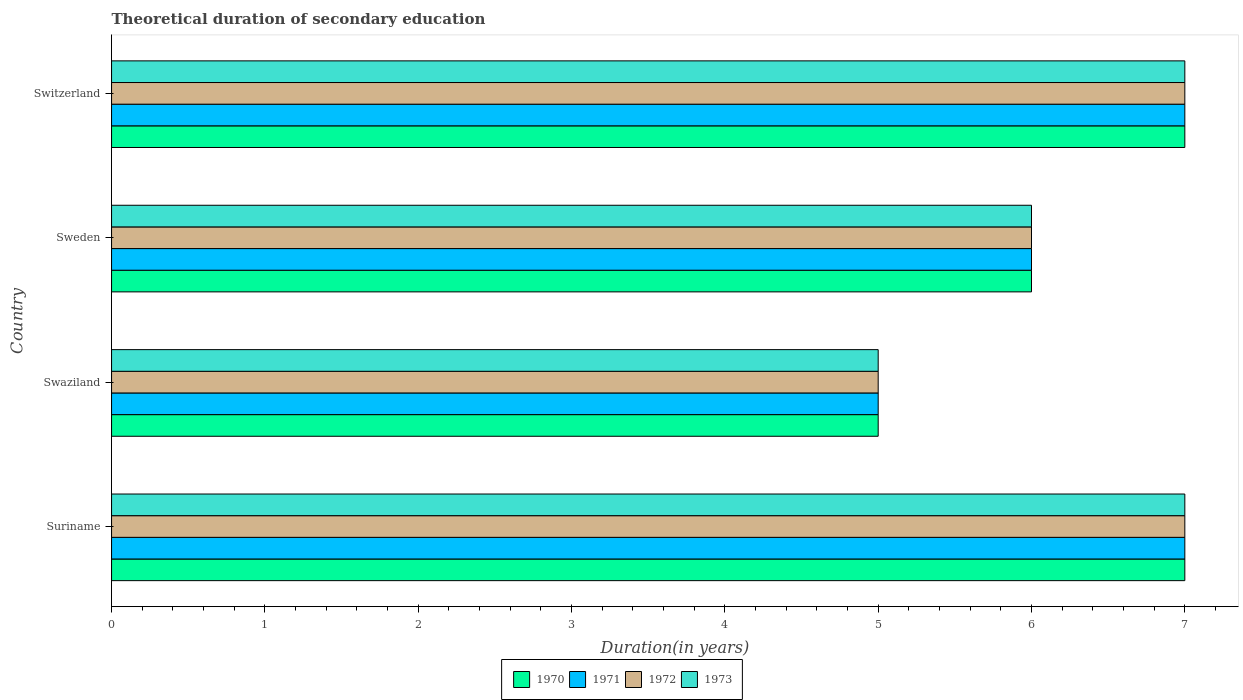Are the number of bars on each tick of the Y-axis equal?
Offer a terse response. Yes. How many bars are there on the 3rd tick from the top?
Offer a terse response. 4. How many bars are there on the 4th tick from the bottom?
Make the answer very short. 4. What is the label of the 1st group of bars from the top?
Provide a succinct answer. Switzerland. Across all countries, what is the minimum total theoretical duration of secondary education in 1971?
Your answer should be compact. 5. In which country was the total theoretical duration of secondary education in 1970 maximum?
Your response must be concise. Suriname. In which country was the total theoretical duration of secondary education in 1971 minimum?
Offer a terse response. Swaziland. What is the difference between the total theoretical duration of secondary education in 1973 in Switzerland and the total theoretical duration of secondary education in 1971 in Suriname?
Keep it short and to the point. 0. What is the average total theoretical duration of secondary education in 1972 per country?
Ensure brevity in your answer.  6.25. In how many countries, is the total theoretical duration of secondary education in 1970 greater than 3.8 years?
Give a very brief answer. 4. What is the ratio of the total theoretical duration of secondary education in 1973 in Suriname to that in Sweden?
Offer a terse response. 1.17. Is the total theoretical duration of secondary education in 1972 in Suriname less than that in Sweden?
Offer a very short reply. No. Is the difference between the total theoretical duration of secondary education in 1970 in Suriname and Swaziland greater than the difference between the total theoretical duration of secondary education in 1973 in Suriname and Swaziland?
Your response must be concise. No. What is the difference between the highest and the lowest total theoretical duration of secondary education in 1972?
Your answer should be compact. 2. Is the sum of the total theoretical duration of secondary education in 1972 in Swaziland and Sweden greater than the maximum total theoretical duration of secondary education in 1971 across all countries?
Provide a short and direct response. Yes. What does the 1st bar from the top in Sweden represents?
Keep it short and to the point. 1973. What does the 3rd bar from the bottom in Swaziland represents?
Provide a succinct answer. 1972. How many bars are there?
Your response must be concise. 16. What is the difference between two consecutive major ticks on the X-axis?
Keep it short and to the point. 1. Does the graph contain grids?
Ensure brevity in your answer.  No. How many legend labels are there?
Your answer should be compact. 4. What is the title of the graph?
Your answer should be compact. Theoretical duration of secondary education. What is the label or title of the X-axis?
Provide a short and direct response. Duration(in years). What is the label or title of the Y-axis?
Give a very brief answer. Country. What is the Duration(in years) of 1971 in Suriname?
Ensure brevity in your answer.  7. What is the Duration(in years) of 1972 in Suriname?
Your answer should be compact. 7. What is the Duration(in years) of 1971 in Swaziland?
Keep it short and to the point. 5. What is the Duration(in years) of 1973 in Swaziland?
Provide a short and direct response. 5. What is the Duration(in years) of 1970 in Sweden?
Make the answer very short. 6. What is the Duration(in years) in 1972 in Sweden?
Offer a terse response. 6. What is the Duration(in years) in 1970 in Switzerland?
Keep it short and to the point. 7. What is the Duration(in years) of 1971 in Switzerland?
Ensure brevity in your answer.  7. What is the Duration(in years) in 1972 in Switzerland?
Provide a succinct answer. 7. Across all countries, what is the maximum Duration(in years) in 1970?
Keep it short and to the point. 7. Across all countries, what is the maximum Duration(in years) of 1971?
Make the answer very short. 7. Across all countries, what is the maximum Duration(in years) of 1972?
Ensure brevity in your answer.  7. Across all countries, what is the minimum Duration(in years) of 1971?
Your answer should be compact. 5. Across all countries, what is the minimum Duration(in years) of 1972?
Offer a very short reply. 5. Across all countries, what is the minimum Duration(in years) in 1973?
Offer a terse response. 5. What is the total Duration(in years) of 1972 in the graph?
Offer a very short reply. 25. What is the total Duration(in years) of 1973 in the graph?
Offer a terse response. 25. What is the difference between the Duration(in years) in 1972 in Suriname and that in Swaziland?
Give a very brief answer. 2. What is the difference between the Duration(in years) of 1971 in Suriname and that in Sweden?
Offer a terse response. 1. What is the difference between the Duration(in years) in 1972 in Suriname and that in Sweden?
Your response must be concise. 1. What is the difference between the Duration(in years) in 1973 in Suriname and that in Sweden?
Provide a succinct answer. 1. What is the difference between the Duration(in years) of 1970 in Suriname and that in Switzerland?
Your answer should be very brief. 0. What is the difference between the Duration(in years) in 1971 in Suriname and that in Switzerland?
Make the answer very short. 0. What is the difference between the Duration(in years) of 1971 in Swaziland and that in Sweden?
Give a very brief answer. -1. What is the difference between the Duration(in years) in 1972 in Swaziland and that in Sweden?
Offer a terse response. -1. What is the difference between the Duration(in years) of 1973 in Swaziland and that in Sweden?
Provide a succinct answer. -1. What is the difference between the Duration(in years) of 1973 in Sweden and that in Switzerland?
Your answer should be very brief. -1. What is the difference between the Duration(in years) of 1971 in Suriname and the Duration(in years) of 1973 in Swaziland?
Keep it short and to the point. 2. What is the difference between the Duration(in years) in 1972 in Suriname and the Duration(in years) in 1973 in Swaziland?
Give a very brief answer. 2. What is the difference between the Duration(in years) of 1970 in Suriname and the Duration(in years) of 1971 in Sweden?
Your answer should be compact. 1. What is the difference between the Duration(in years) of 1970 in Suriname and the Duration(in years) of 1972 in Sweden?
Your answer should be very brief. 1. What is the difference between the Duration(in years) in 1970 in Suriname and the Duration(in years) in 1971 in Switzerland?
Make the answer very short. 0. What is the difference between the Duration(in years) of 1970 in Suriname and the Duration(in years) of 1972 in Switzerland?
Your answer should be very brief. 0. What is the difference between the Duration(in years) of 1970 in Suriname and the Duration(in years) of 1973 in Switzerland?
Provide a short and direct response. 0. What is the difference between the Duration(in years) in 1970 in Swaziland and the Duration(in years) in 1971 in Sweden?
Your answer should be very brief. -1. What is the difference between the Duration(in years) of 1970 in Swaziland and the Duration(in years) of 1972 in Sweden?
Make the answer very short. -1. What is the difference between the Duration(in years) of 1971 in Swaziland and the Duration(in years) of 1972 in Sweden?
Ensure brevity in your answer.  -1. What is the difference between the Duration(in years) in 1970 in Swaziland and the Duration(in years) in 1973 in Switzerland?
Your answer should be compact. -2. What is the difference between the Duration(in years) in 1971 in Swaziland and the Duration(in years) in 1972 in Switzerland?
Keep it short and to the point. -2. What is the difference between the Duration(in years) of 1971 in Swaziland and the Duration(in years) of 1973 in Switzerland?
Ensure brevity in your answer.  -2. What is the difference between the Duration(in years) in 1970 in Sweden and the Duration(in years) in 1972 in Switzerland?
Offer a very short reply. -1. What is the difference between the Duration(in years) in 1970 in Sweden and the Duration(in years) in 1973 in Switzerland?
Provide a succinct answer. -1. What is the difference between the Duration(in years) in 1971 in Sweden and the Duration(in years) in 1972 in Switzerland?
Make the answer very short. -1. What is the difference between the Duration(in years) in 1971 in Sweden and the Duration(in years) in 1973 in Switzerland?
Your response must be concise. -1. What is the average Duration(in years) in 1970 per country?
Your answer should be very brief. 6.25. What is the average Duration(in years) in 1971 per country?
Provide a short and direct response. 6.25. What is the average Duration(in years) in 1972 per country?
Provide a succinct answer. 6.25. What is the average Duration(in years) in 1973 per country?
Your answer should be compact. 6.25. What is the difference between the Duration(in years) of 1970 and Duration(in years) of 1971 in Suriname?
Provide a short and direct response. 0. What is the difference between the Duration(in years) of 1970 and Duration(in years) of 1972 in Suriname?
Make the answer very short. 0. What is the difference between the Duration(in years) in 1970 and Duration(in years) in 1973 in Suriname?
Offer a very short reply. 0. What is the difference between the Duration(in years) of 1971 and Duration(in years) of 1972 in Suriname?
Give a very brief answer. 0. What is the difference between the Duration(in years) in 1971 and Duration(in years) in 1973 in Suriname?
Make the answer very short. 0. What is the difference between the Duration(in years) of 1970 and Duration(in years) of 1973 in Swaziland?
Provide a short and direct response. 0. What is the difference between the Duration(in years) in 1971 and Duration(in years) in 1972 in Swaziland?
Provide a short and direct response. 0. What is the difference between the Duration(in years) in 1972 and Duration(in years) in 1973 in Swaziland?
Make the answer very short. 0. What is the difference between the Duration(in years) of 1970 and Duration(in years) of 1971 in Sweden?
Offer a terse response. 0. What is the difference between the Duration(in years) of 1970 and Duration(in years) of 1973 in Sweden?
Ensure brevity in your answer.  0. What is the difference between the Duration(in years) of 1970 and Duration(in years) of 1972 in Switzerland?
Your response must be concise. 0. What is the difference between the Duration(in years) of 1972 and Duration(in years) of 1973 in Switzerland?
Your answer should be compact. 0. What is the ratio of the Duration(in years) of 1972 in Suriname to that in Swaziland?
Ensure brevity in your answer.  1.4. What is the ratio of the Duration(in years) of 1971 in Suriname to that in Sweden?
Your answer should be compact. 1.17. What is the ratio of the Duration(in years) of 1972 in Suriname to that in Sweden?
Your answer should be very brief. 1.17. What is the ratio of the Duration(in years) in 1970 in Suriname to that in Switzerland?
Your answer should be compact. 1. What is the ratio of the Duration(in years) in 1971 in Swaziland to that in Sweden?
Ensure brevity in your answer.  0.83. What is the ratio of the Duration(in years) in 1972 in Swaziland to that in Sweden?
Make the answer very short. 0.83. What is the ratio of the Duration(in years) in 1973 in Swaziland to that in Sweden?
Your answer should be very brief. 0.83. What is the ratio of the Duration(in years) of 1971 in Swaziland to that in Switzerland?
Provide a succinct answer. 0.71. What is the ratio of the Duration(in years) in 1972 in Swaziland to that in Switzerland?
Provide a succinct answer. 0.71. What is the ratio of the Duration(in years) in 1970 in Sweden to that in Switzerland?
Your answer should be very brief. 0.86. What is the ratio of the Duration(in years) of 1971 in Sweden to that in Switzerland?
Your answer should be compact. 0.86. What is the difference between the highest and the second highest Duration(in years) in 1970?
Ensure brevity in your answer.  0. What is the difference between the highest and the second highest Duration(in years) in 1972?
Offer a terse response. 0. What is the difference between the highest and the lowest Duration(in years) of 1970?
Your response must be concise. 2. What is the difference between the highest and the lowest Duration(in years) in 1971?
Your answer should be very brief. 2. What is the difference between the highest and the lowest Duration(in years) in 1973?
Offer a very short reply. 2. 